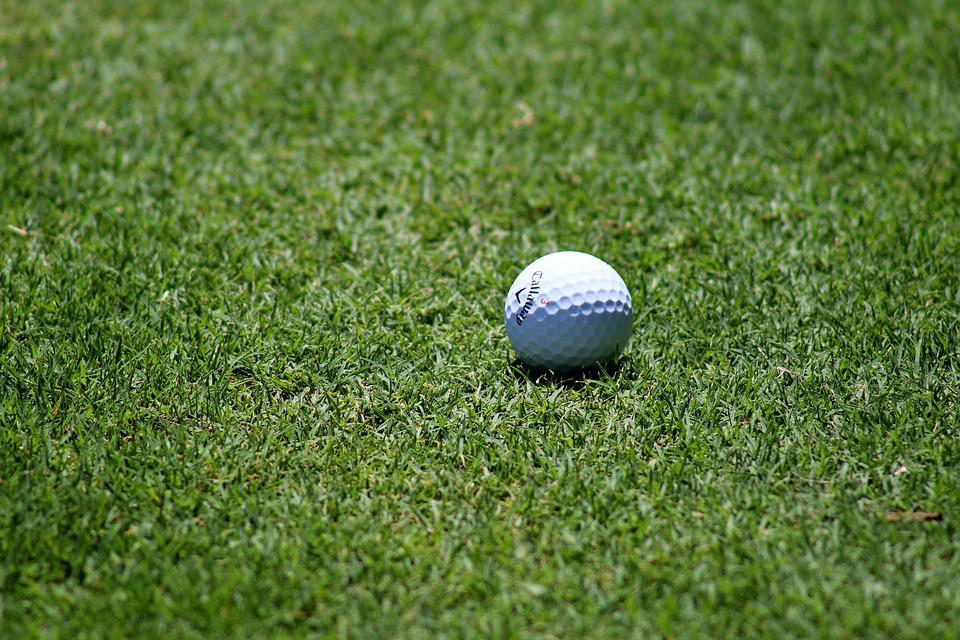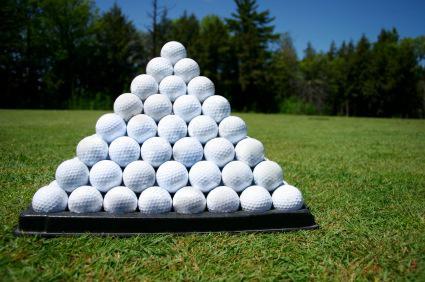The first image is the image on the left, the second image is the image on the right. Considering the images on both sides, is "in 1 of the images, 1 white golf ball is sitting in grass." valid? Answer yes or no. Yes. The first image is the image on the left, the second image is the image on the right. For the images shown, is this caption "Exactly four golf balls are arranged on grass in one image." true? Answer yes or no. No. 